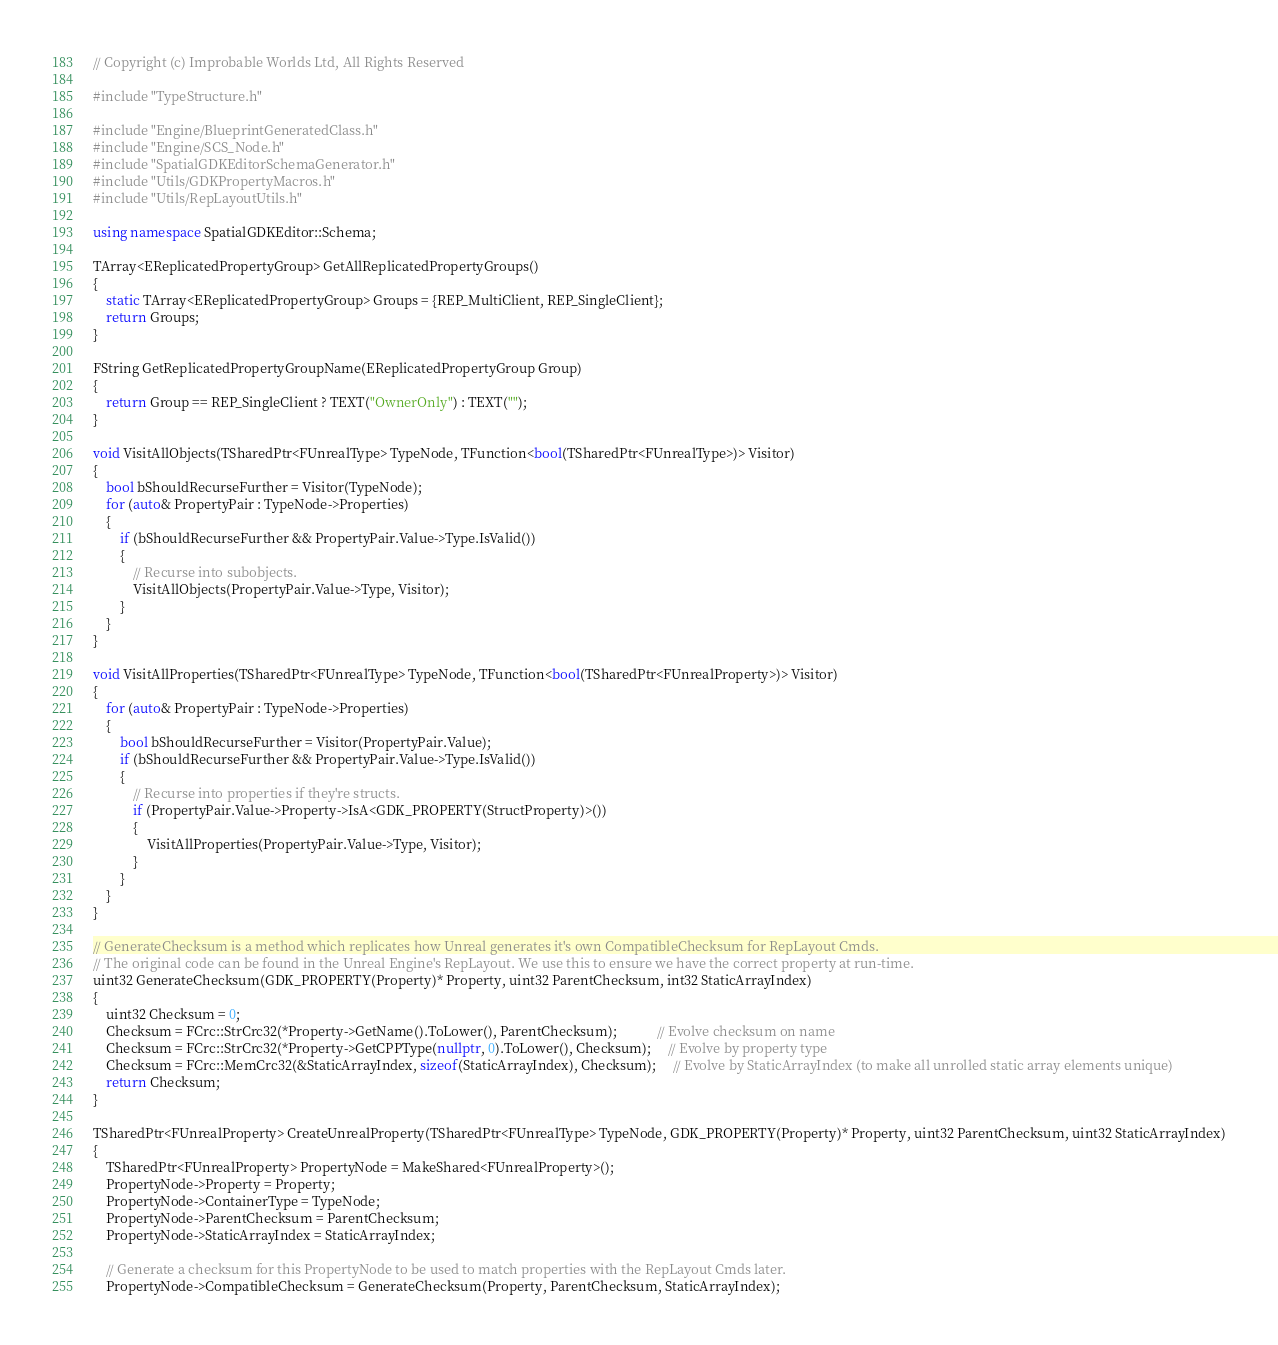Convert code to text. <code><loc_0><loc_0><loc_500><loc_500><_C++_>// Copyright (c) Improbable Worlds Ltd, All Rights Reserved

#include "TypeStructure.h"

#include "Engine/BlueprintGeneratedClass.h"
#include "Engine/SCS_Node.h"
#include "SpatialGDKEditorSchemaGenerator.h"
#include "Utils/GDKPropertyMacros.h"
#include "Utils/RepLayoutUtils.h"

using namespace SpatialGDKEditor::Schema;

TArray<EReplicatedPropertyGroup> GetAllReplicatedPropertyGroups()
{
	static TArray<EReplicatedPropertyGroup> Groups = {REP_MultiClient, REP_SingleClient};
	return Groups;
}

FString GetReplicatedPropertyGroupName(EReplicatedPropertyGroup Group)
{
	return Group == REP_SingleClient ? TEXT("OwnerOnly") : TEXT("");
}

void VisitAllObjects(TSharedPtr<FUnrealType> TypeNode, TFunction<bool(TSharedPtr<FUnrealType>)> Visitor)
{
	bool bShouldRecurseFurther = Visitor(TypeNode);
	for (auto& PropertyPair : TypeNode->Properties)
	{
		if (bShouldRecurseFurther && PropertyPair.Value->Type.IsValid())
		{
			// Recurse into subobjects.
			VisitAllObjects(PropertyPair.Value->Type, Visitor);
		}
	}
}

void VisitAllProperties(TSharedPtr<FUnrealType> TypeNode, TFunction<bool(TSharedPtr<FUnrealProperty>)> Visitor)
{
	for (auto& PropertyPair : TypeNode->Properties)
	{
		bool bShouldRecurseFurther = Visitor(PropertyPair.Value);
		if (bShouldRecurseFurther && PropertyPair.Value->Type.IsValid())
		{
			// Recurse into properties if they're structs.
			if (PropertyPair.Value->Property->IsA<GDK_PROPERTY(StructProperty)>())
			{
				VisitAllProperties(PropertyPair.Value->Type, Visitor);
			}
		}
	}
}

// GenerateChecksum is a method which replicates how Unreal generates it's own CompatibleChecksum for RepLayout Cmds.
// The original code can be found in the Unreal Engine's RepLayout. We use this to ensure we have the correct property at run-time.
uint32 GenerateChecksum(GDK_PROPERTY(Property)* Property, uint32 ParentChecksum, int32 StaticArrayIndex)
{
	uint32 Checksum = 0;
	Checksum = FCrc::StrCrc32(*Property->GetName().ToLower(), ParentChecksum);            // Evolve checksum on name
	Checksum = FCrc::StrCrc32(*Property->GetCPPType(nullptr, 0).ToLower(), Checksum);     // Evolve by property type
	Checksum = FCrc::MemCrc32(&StaticArrayIndex, sizeof(StaticArrayIndex), Checksum);     // Evolve by StaticArrayIndex (to make all unrolled static array elements unique)
	return Checksum;
}

TSharedPtr<FUnrealProperty> CreateUnrealProperty(TSharedPtr<FUnrealType> TypeNode, GDK_PROPERTY(Property)* Property, uint32 ParentChecksum, uint32 StaticArrayIndex)
{
	TSharedPtr<FUnrealProperty> PropertyNode = MakeShared<FUnrealProperty>();
	PropertyNode->Property = Property;
	PropertyNode->ContainerType = TypeNode;
	PropertyNode->ParentChecksum = ParentChecksum;
	PropertyNode->StaticArrayIndex = StaticArrayIndex;

	// Generate a checksum for this PropertyNode to be used to match properties with the RepLayout Cmds later.
	PropertyNode->CompatibleChecksum = GenerateChecksum(Property, ParentChecksum, StaticArrayIndex);</code> 